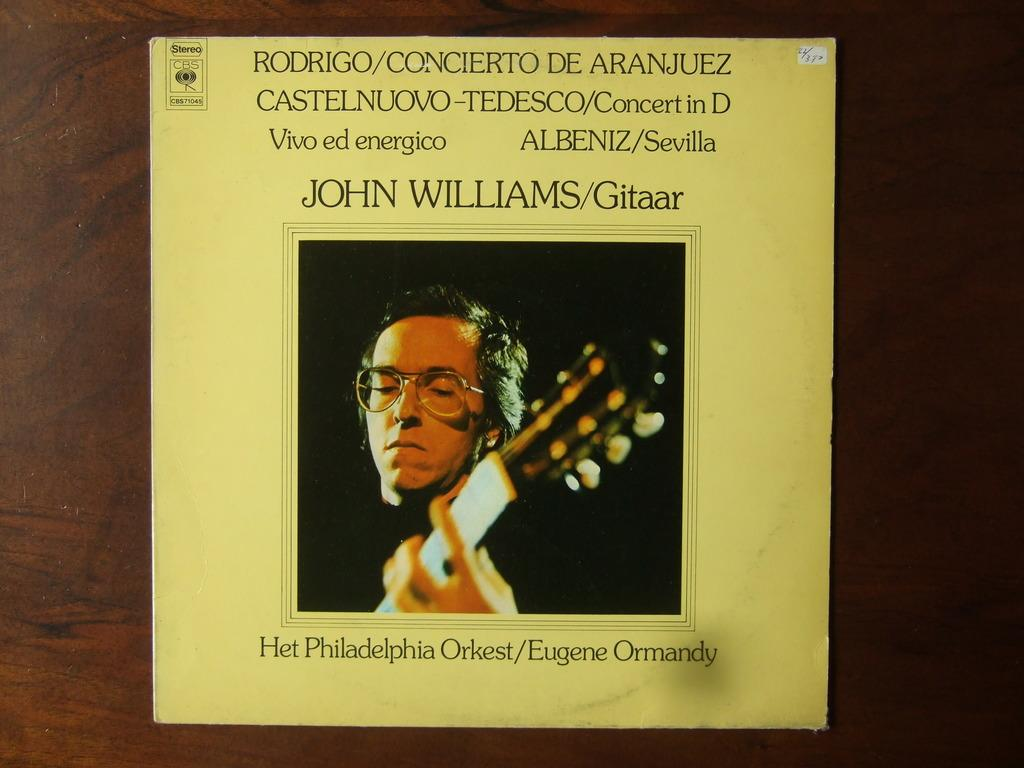<image>
Present a compact description of the photo's key features. John Williams part of the Philadelphia Orkest/Eugene Ormandy. 